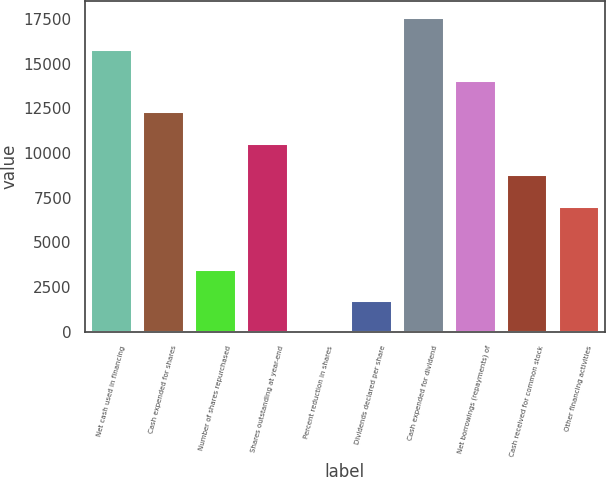Convert chart to OTSL. <chart><loc_0><loc_0><loc_500><loc_500><bar_chart><fcel>Net cash used in financing<fcel>Cash expended for shares<fcel>Number of shares repurchased<fcel>Shares outstanding at year-end<fcel>Percent reduction in shares<fcel>Dividends declared per share<fcel>Cash expended for dividend<fcel>Net borrowings (repayments) of<fcel>Cash received for common stock<fcel>Other financing activities<nl><fcel>15842.8<fcel>12322.4<fcel>3521.4<fcel>10562.2<fcel>1<fcel>1761.2<fcel>17603<fcel>14082.6<fcel>8802<fcel>7041.8<nl></chart> 